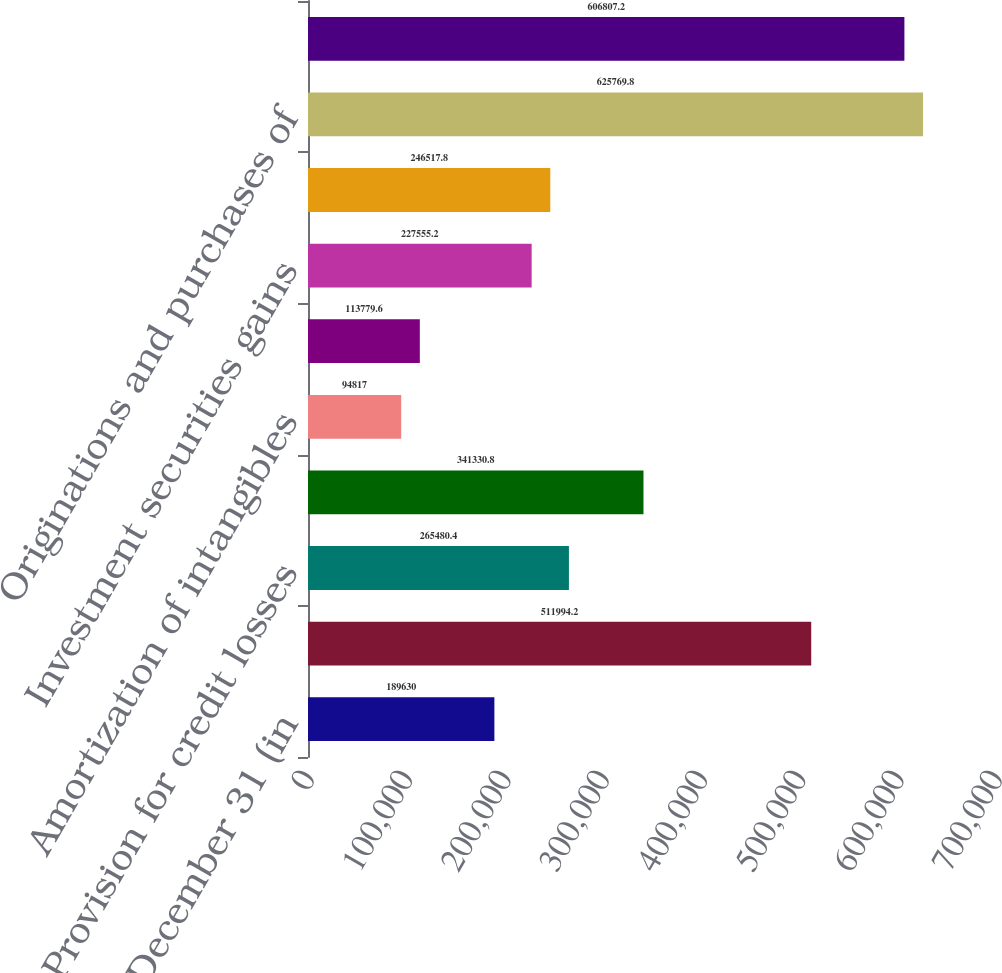<chart> <loc_0><loc_0><loc_500><loc_500><bar_chart><fcel>Year ended December 31 (in<fcel>Net income<fcel>Provision for credit losses<fcel>Depreciation and amortization<fcel>Amortization of intangibles<fcel>Deferred tax expense<fcel>Investment securities gains<fcel>Stock-based compensation<fcel>Originations and purchases of<fcel>Proceeds from sales<nl><fcel>189630<fcel>511994<fcel>265480<fcel>341331<fcel>94817<fcel>113780<fcel>227555<fcel>246518<fcel>625770<fcel>606807<nl></chart> 